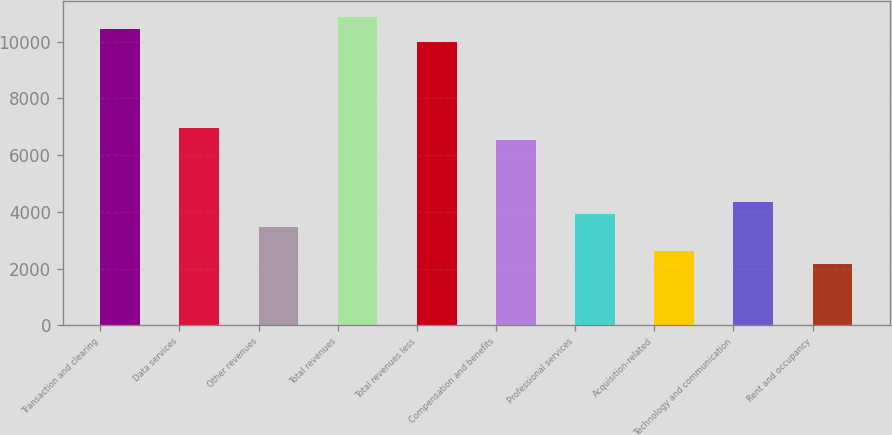<chart> <loc_0><loc_0><loc_500><loc_500><bar_chart><fcel>Transaction and clearing<fcel>Data services<fcel>Other revenues<fcel>Total revenues<fcel>Total revenues less<fcel>Compensation and benefits<fcel>Professional services<fcel>Acquisition-related<fcel>Technology and communication<fcel>Rent and occupancy<nl><fcel>10442.4<fcel>6962.18<fcel>3481.94<fcel>10877.5<fcel>10007.4<fcel>6527.15<fcel>3916.97<fcel>2611.88<fcel>4352<fcel>2176.85<nl></chart> 